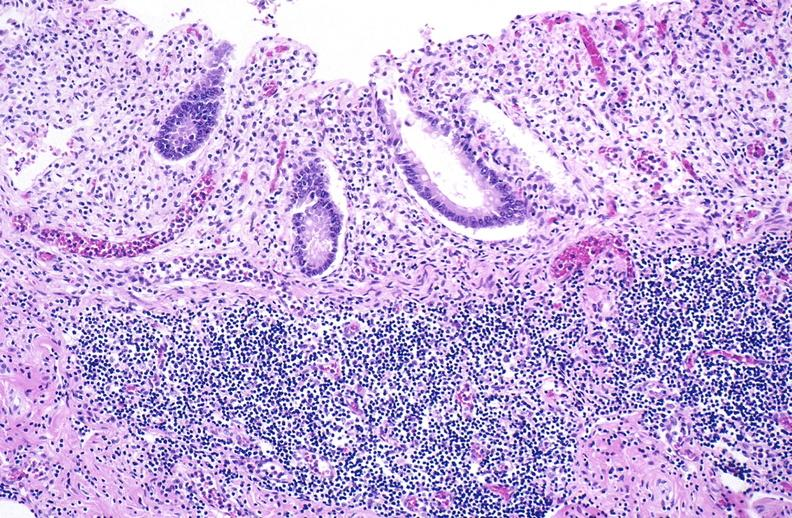what is present?
Answer the question using a single word or phrase. Gastrointestinal 